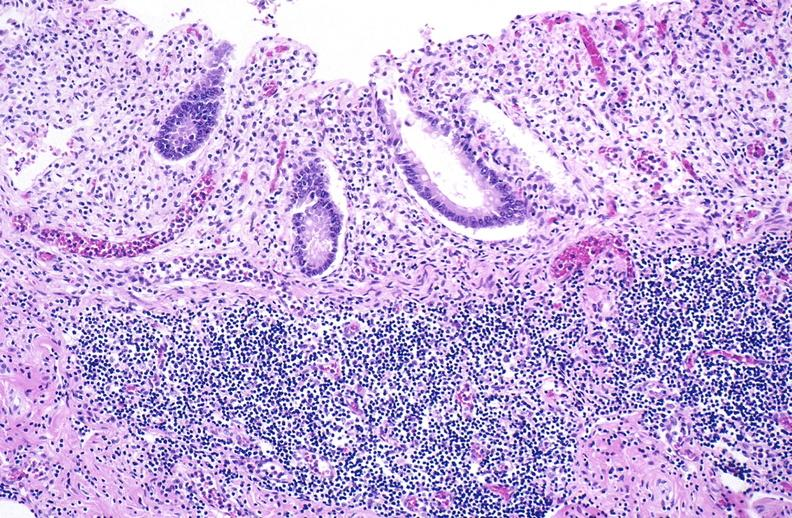what is present?
Answer the question using a single word or phrase. Gastrointestinal 